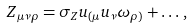Convert formula to latex. <formula><loc_0><loc_0><loc_500><loc_500>Z _ { \mu \nu \rho } = \sigma _ { Z } u _ { ( \mu } u _ { \nu } \omega _ { \rho ) } + \dots \, ,</formula> 